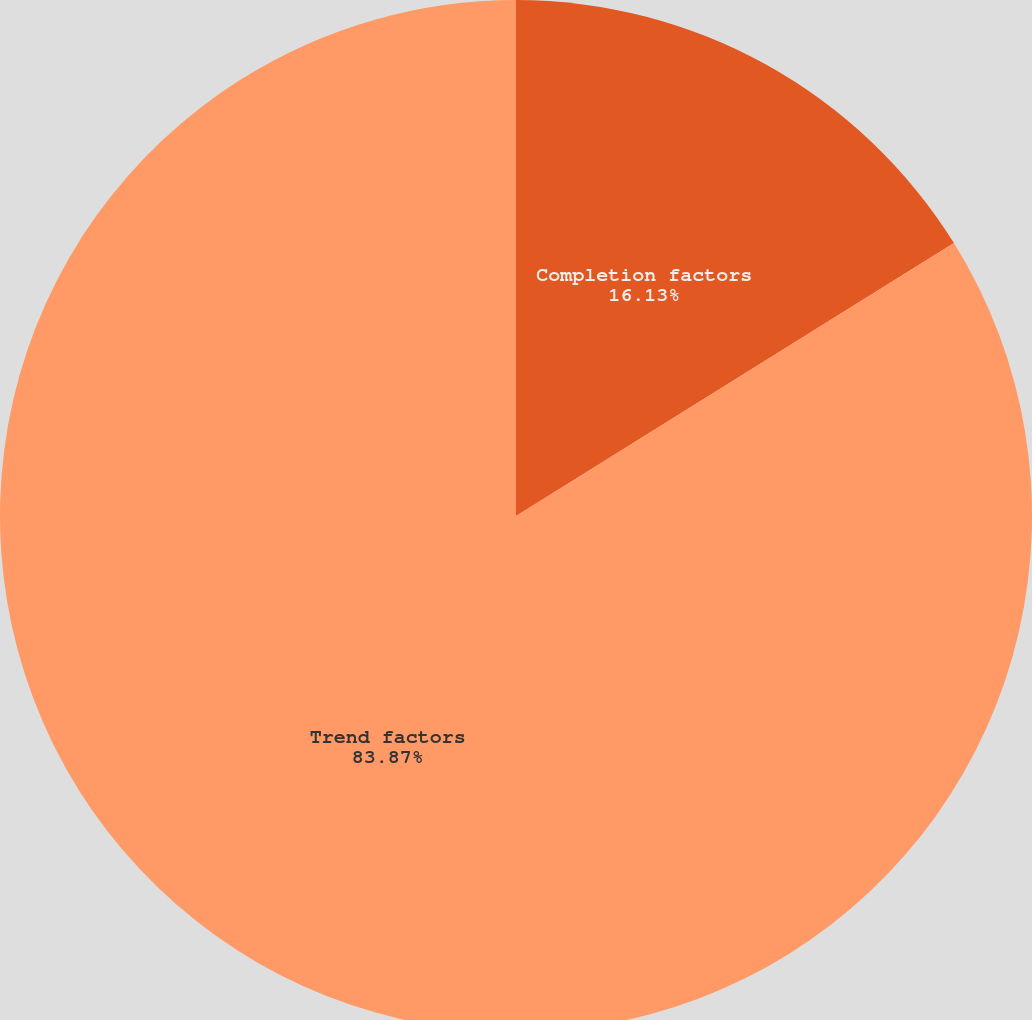<chart> <loc_0><loc_0><loc_500><loc_500><pie_chart><fcel>Completion factors<fcel>Trend factors<nl><fcel>16.13%<fcel>83.87%<nl></chart> 